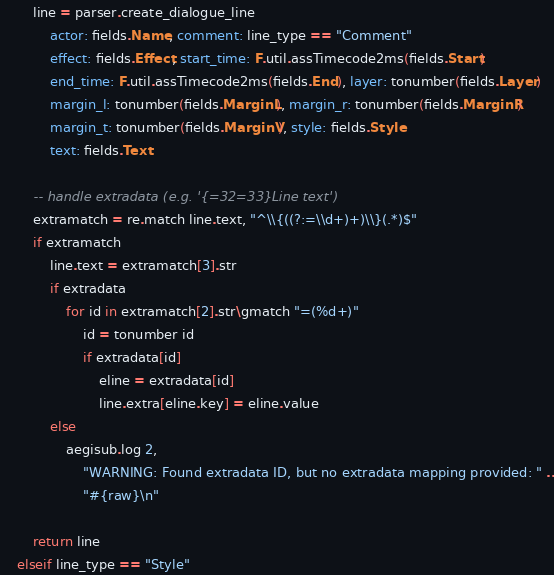Convert code to text. <code><loc_0><loc_0><loc_500><loc_500><_MoonScript_>        line = parser.create_dialogue_line
            actor: fields.Name, comment: line_type == "Comment"
            effect: fields.Effect, start_time: F.util.assTimecode2ms(fields.Start)
            end_time: F.util.assTimecode2ms(fields.End), layer: tonumber(fields.Layer)
            margin_l: tonumber(fields.MarginL), margin_r: tonumber(fields.MarginR)
            margin_t: tonumber(fields.MarginV), style: fields.Style
            text: fields.Text

        -- handle extradata (e.g. '{=32=33}Line text')
        extramatch = re.match line.text, "^\\{((?:=\\d+)+)\\}(.*)$"
        if extramatch
            line.text = extramatch[3].str
            if extradata
                for id in extramatch[2].str\gmatch "=(%d+)"
                    id = tonumber id
                    if extradata[id]
                        eline = extradata[id]
                        line.extra[eline.key] = eline.value
            else
                aegisub.log 2,
                    "WARNING: Found extradata ID, but no extradata mapping provided: " ..
                    "#{raw}\n"

        return line
    elseif line_type == "Style"</code> 